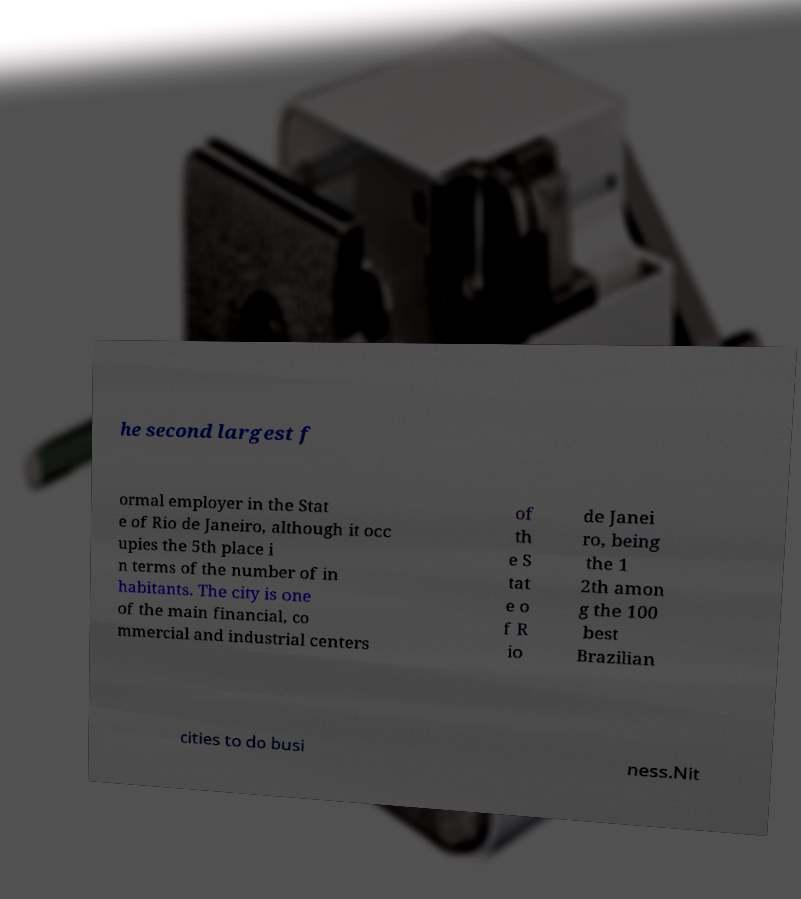What messages or text are displayed in this image? I need them in a readable, typed format. he second largest f ormal employer in the Stat e of Rio de Janeiro, although it occ upies the 5th place i n terms of the number of in habitants. The city is one of the main financial, co mmercial and industrial centers of th e S tat e o f R io de Janei ro, being the 1 2th amon g the 100 best Brazilian cities to do busi ness.Nit 